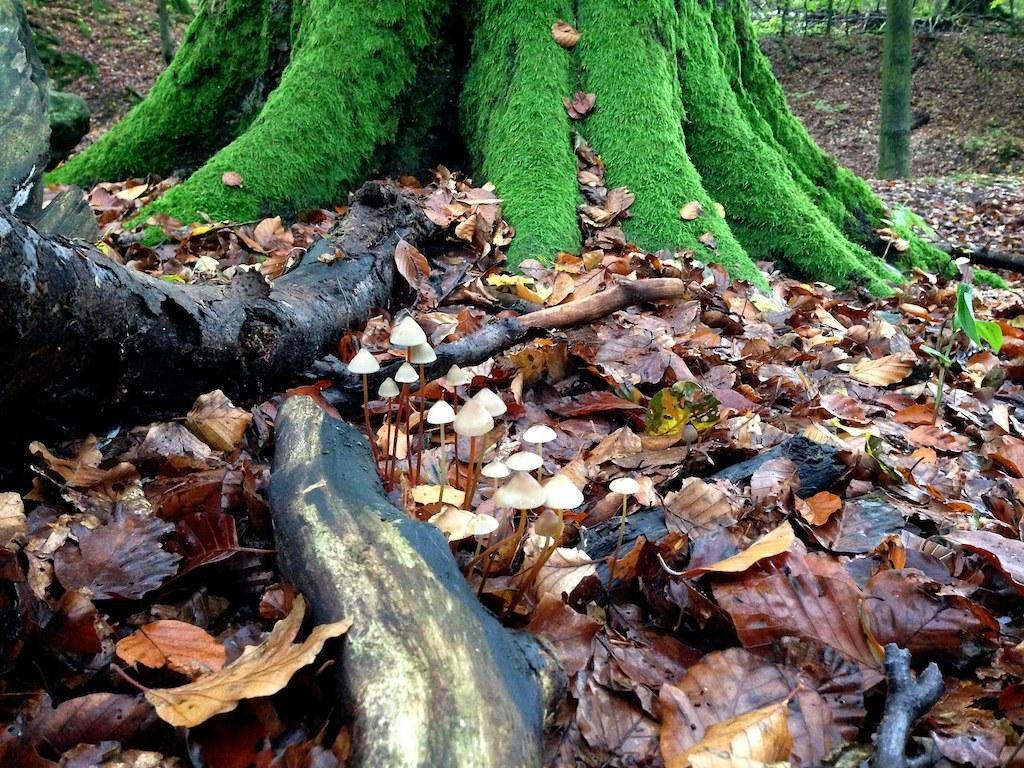What types of plants can be seen in the foreground of the image? There are mushrooms in the foreground of the image. What else can be found in the foreground of the image? Dry leaves and tree trunks are present in the foreground of the image. Are there any tree trunks visible at the top of the image? Yes, tree trunks are present at the top of the image. What type of terrain is visible at the top of the image? The land is visible at the top of the image. What type of rat can be seen climbing the tree trunk in the image? There is no rat present in the image; it only features mushrooms, dry leaves, and tree trunks. 